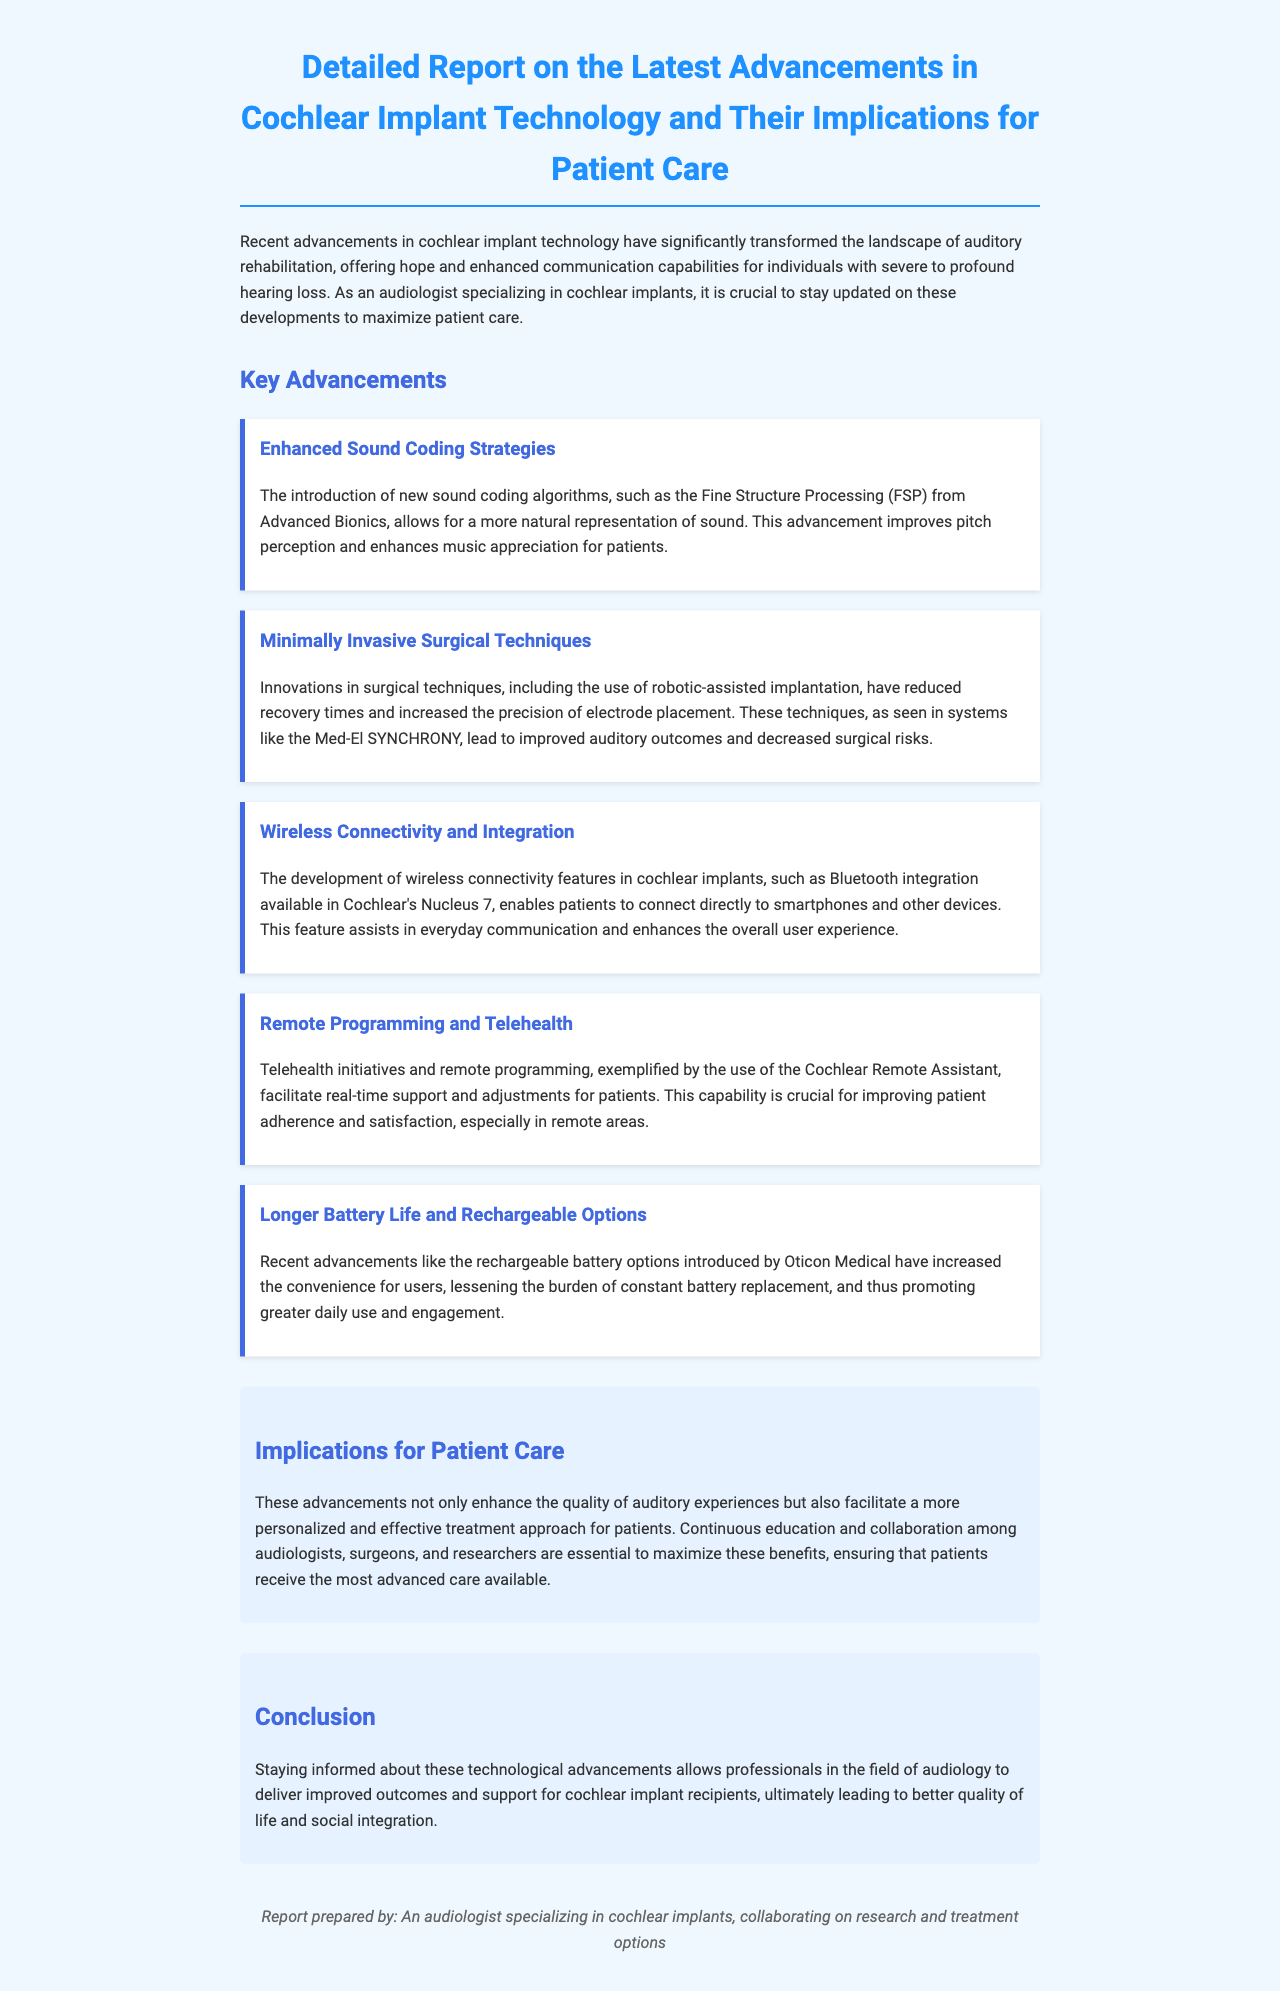What is the title of the document? The title is stated at the beginning of the document and summarizes its main topic.
Answer: Detailed Report on the Latest Advancements in Cochlear Implant Technology and Their Implications for Patient Care What is a new sound coding algorithm mentioned? The document lists enhanced sound coding strategies including specific algorithms that improve pitch perception.
Answer: Fine Structure Processing Which company introduced the robotic-assisted implantation? The report provides information on innovations in surgical techniques and mentions companies associated with these advancements.
Answer: Med-El What feature does Cochlear's Nucleus 7 provide? The document highlights specific features of cochlear implants that improve patient experience.
Answer: Bluetooth integration What is the primary benefit of remote programming in cochlear implants? The implications section discusses the role of telehealth and remote programming in patient care.
Answer: Real-time support How has battery life changed according to the advancements? The report discusses new battery options designed to enhance user convenience and engagement.
Answer: Rechargeable options What do these advancements allow professionals to deliver? The conclusion summarizes the outcomes that audiologists can achieve by staying informed about technology.
Answer: Improved outcomes How many key advancements are discussed in the document? The document lists specific advancements highlighting the advancements in cochlear implant technology.
Answer: Five 